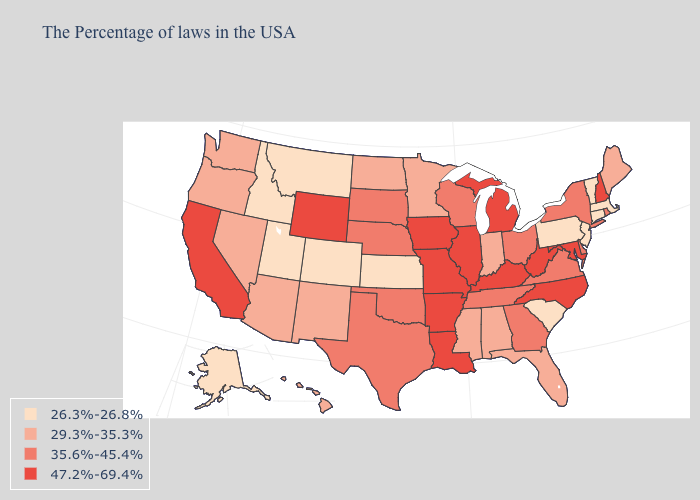Does the first symbol in the legend represent the smallest category?
Give a very brief answer. Yes. What is the highest value in the USA?
Short answer required. 47.2%-69.4%. Name the states that have a value in the range 29.3%-35.3%?
Be succinct. Maine, Florida, Indiana, Alabama, Mississippi, Minnesota, North Dakota, New Mexico, Arizona, Nevada, Washington, Oregon, Hawaii. Name the states that have a value in the range 47.2%-69.4%?
Write a very short answer. New Hampshire, Maryland, North Carolina, West Virginia, Michigan, Kentucky, Illinois, Louisiana, Missouri, Arkansas, Iowa, Wyoming, California. What is the value of Louisiana?
Give a very brief answer. 47.2%-69.4%. Does Pennsylvania have the same value as New Jersey?
Concise answer only. Yes. What is the value of Ohio?
Answer briefly. 35.6%-45.4%. Which states have the lowest value in the West?
Quick response, please. Colorado, Utah, Montana, Idaho, Alaska. What is the value of North Carolina?
Short answer required. 47.2%-69.4%. How many symbols are there in the legend?
Keep it brief. 4. Name the states that have a value in the range 26.3%-26.8%?
Short answer required. Massachusetts, Vermont, Connecticut, New Jersey, Pennsylvania, South Carolina, Kansas, Colorado, Utah, Montana, Idaho, Alaska. Which states have the lowest value in the USA?
Concise answer only. Massachusetts, Vermont, Connecticut, New Jersey, Pennsylvania, South Carolina, Kansas, Colorado, Utah, Montana, Idaho, Alaska. Among the states that border Maine , which have the lowest value?
Concise answer only. New Hampshire. What is the highest value in the MidWest ?
Keep it brief. 47.2%-69.4%. What is the lowest value in states that border Wyoming?
Concise answer only. 26.3%-26.8%. 